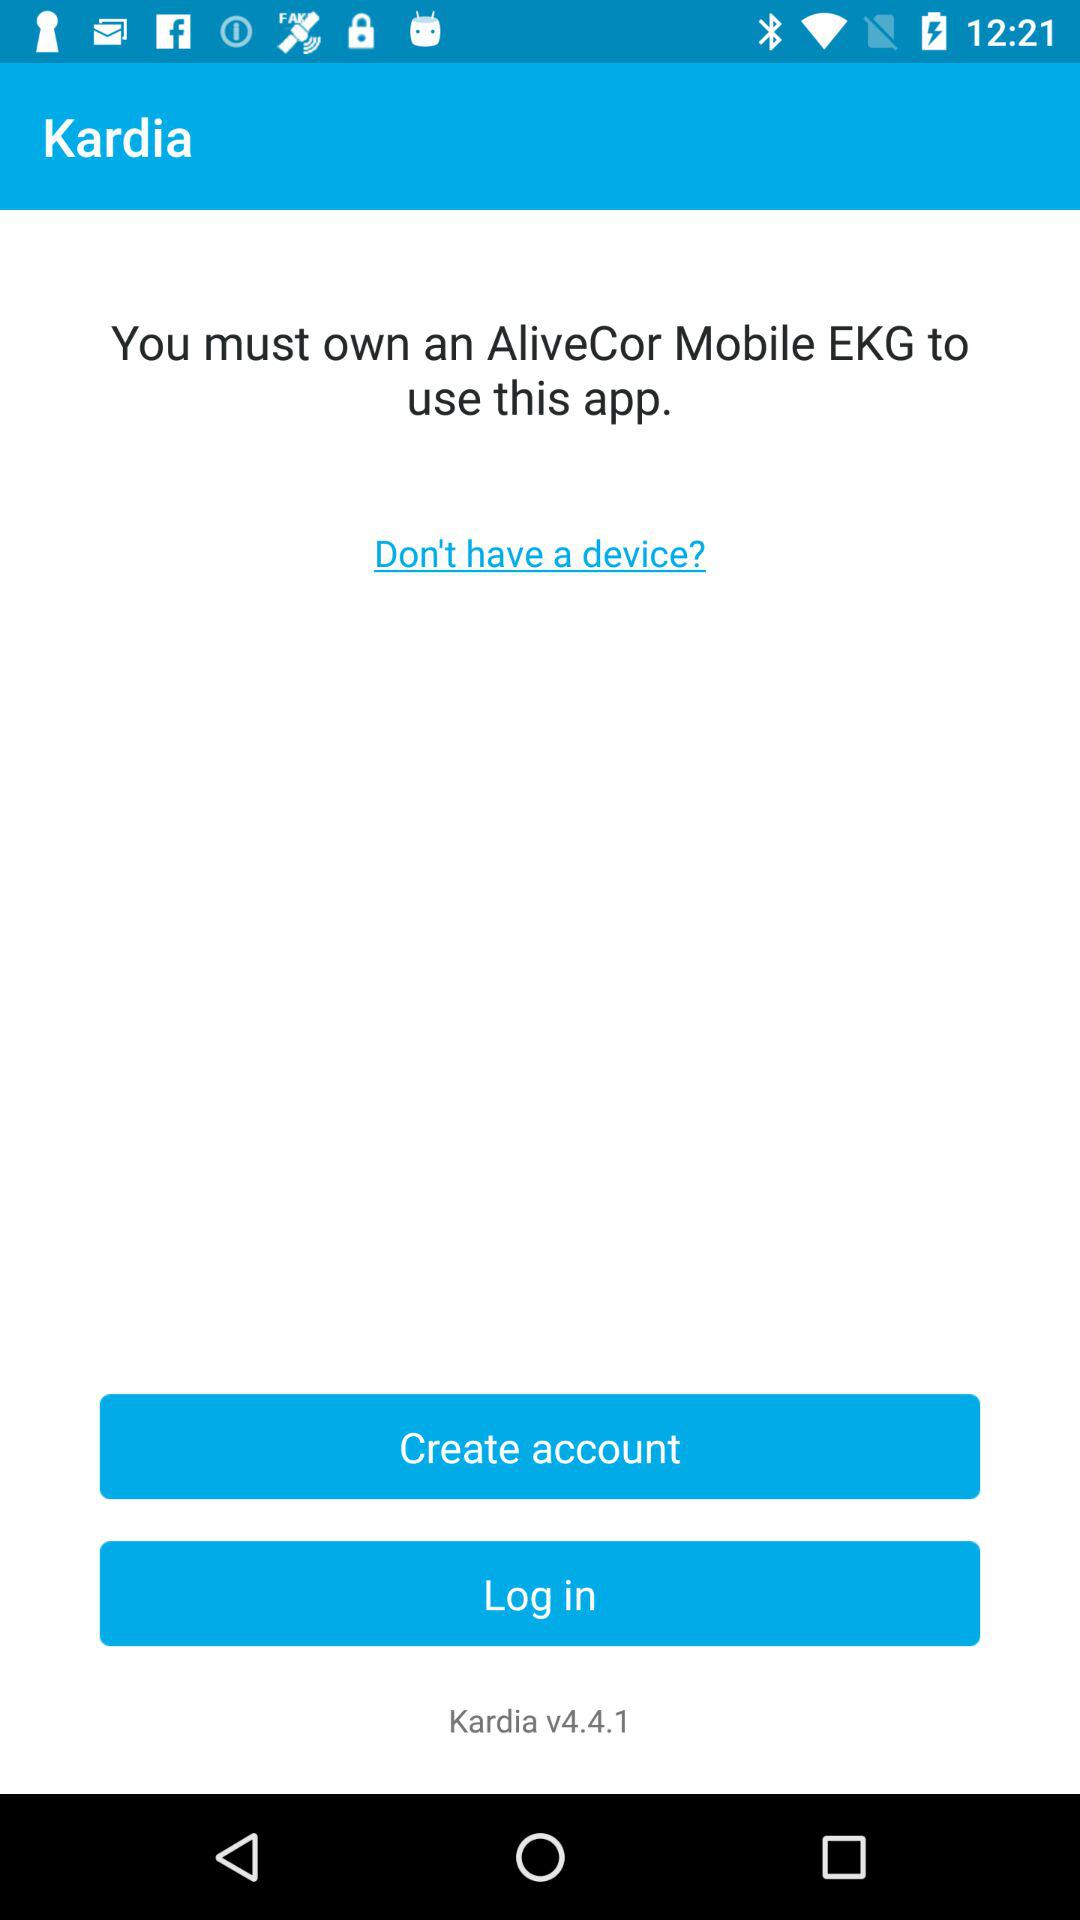What is the app name? The app name is "Kardia". 